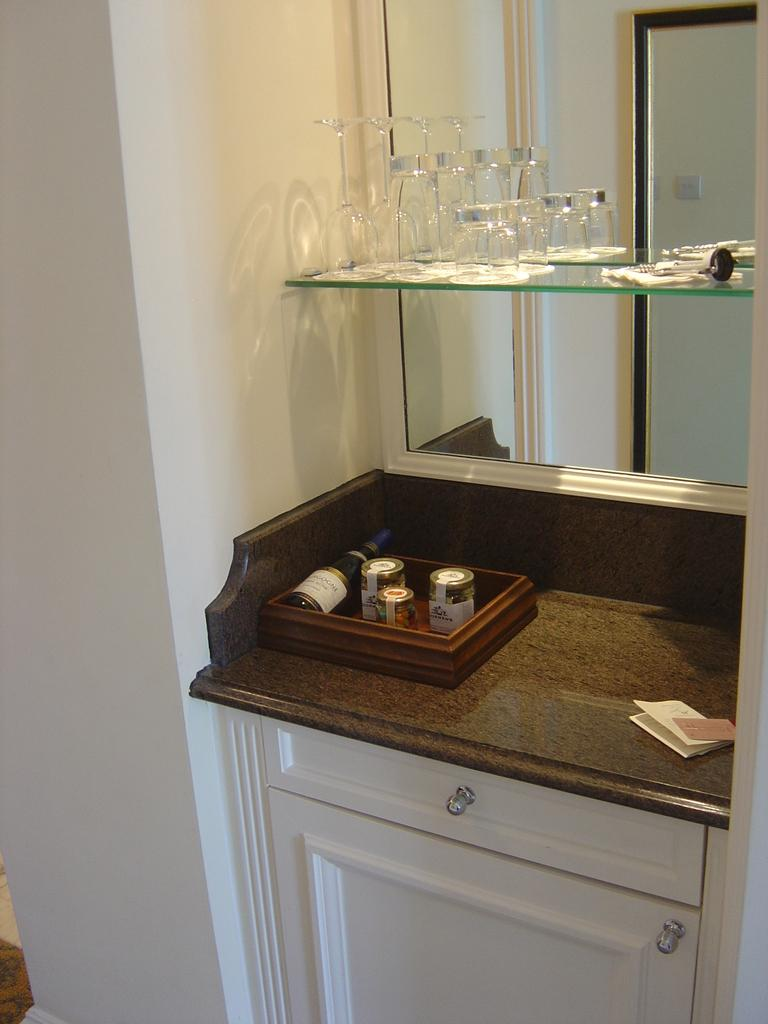What is present on the wall in the image? There is a table on the wall in the image. What is placed on the table? There are papers and bottles on the table. What else can be seen in the image? There is a mirror in the image. What is visible in the mirror? Glasses are visible in the mirror. Can you see a pencil being used to fold a tub in the image? There is no tub, folding, or pencil present in the image. 